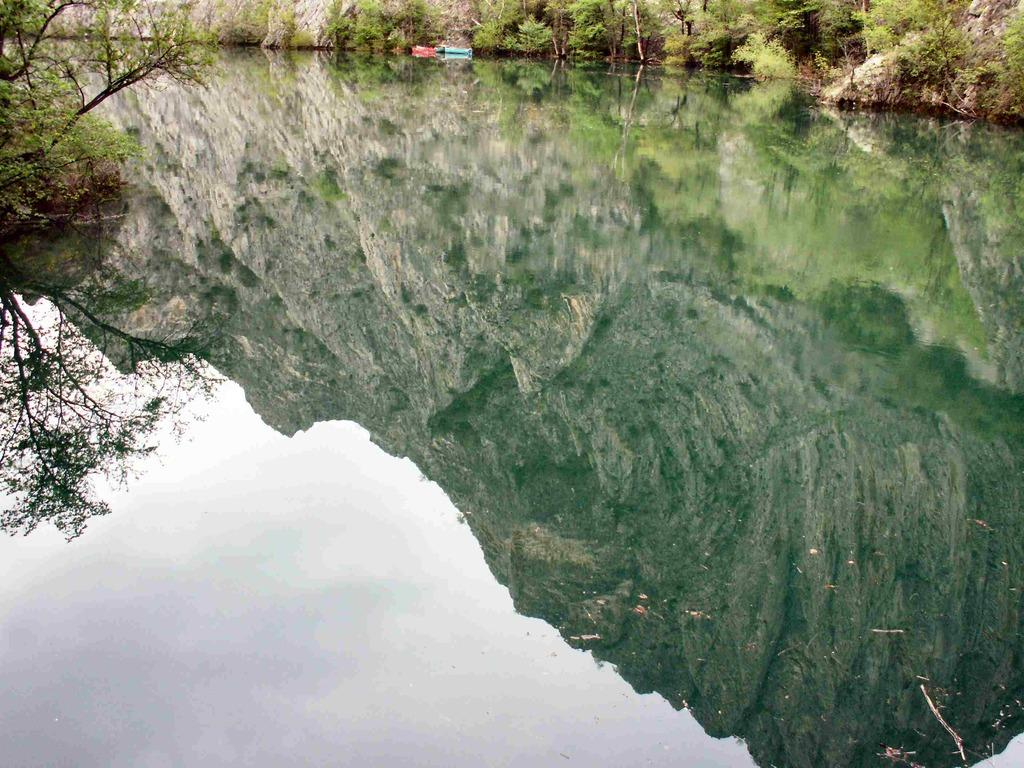What type of water is present in the image? There is river water in the image. What can be seen in the reflection of the water? There is a reflection of a mountain in the water. What type of vegetation is visible in the image? There are trees visible in the image. How many cherries are hanging from the trees in the image? There are no cherries visible in the image; only trees are present. What type of wound can be seen on the mountain in the image? There is no wound visible on the mountain in the image; it is a reflection in the water. 